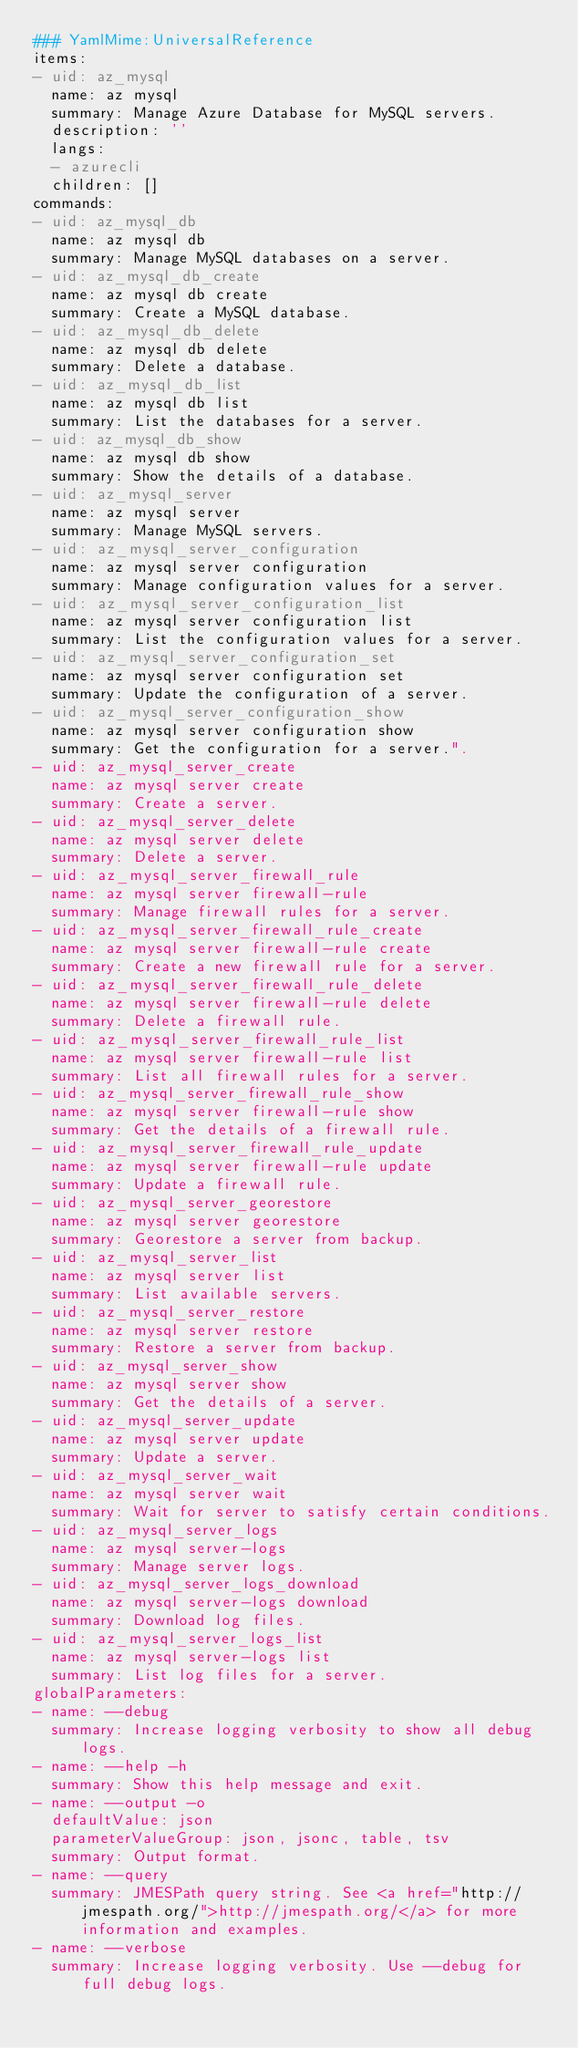Convert code to text. <code><loc_0><loc_0><loc_500><loc_500><_YAML_>### YamlMime:UniversalReference
items:
- uid: az_mysql
  name: az mysql
  summary: Manage Azure Database for MySQL servers.
  description: ''
  langs:
  - azurecli
  children: []
commands:
- uid: az_mysql_db
  name: az mysql db
  summary: Manage MySQL databases on a server.
- uid: az_mysql_db_create
  name: az mysql db create
  summary: Create a MySQL database.
- uid: az_mysql_db_delete
  name: az mysql db delete
  summary: Delete a database.
- uid: az_mysql_db_list
  name: az mysql db list
  summary: List the databases for a server.
- uid: az_mysql_db_show
  name: az mysql db show
  summary: Show the details of a database.
- uid: az_mysql_server
  name: az mysql server
  summary: Manage MySQL servers.
- uid: az_mysql_server_configuration
  name: az mysql server configuration
  summary: Manage configuration values for a server.
- uid: az_mysql_server_configuration_list
  name: az mysql server configuration list
  summary: List the configuration values for a server.
- uid: az_mysql_server_configuration_set
  name: az mysql server configuration set
  summary: Update the configuration of a server.
- uid: az_mysql_server_configuration_show
  name: az mysql server configuration show
  summary: Get the configuration for a server.".
- uid: az_mysql_server_create
  name: az mysql server create
  summary: Create a server.
- uid: az_mysql_server_delete
  name: az mysql server delete
  summary: Delete a server.
- uid: az_mysql_server_firewall_rule
  name: az mysql server firewall-rule
  summary: Manage firewall rules for a server.
- uid: az_mysql_server_firewall_rule_create
  name: az mysql server firewall-rule create
  summary: Create a new firewall rule for a server.
- uid: az_mysql_server_firewall_rule_delete
  name: az mysql server firewall-rule delete
  summary: Delete a firewall rule.
- uid: az_mysql_server_firewall_rule_list
  name: az mysql server firewall-rule list
  summary: List all firewall rules for a server.
- uid: az_mysql_server_firewall_rule_show
  name: az mysql server firewall-rule show
  summary: Get the details of a firewall rule.
- uid: az_mysql_server_firewall_rule_update
  name: az mysql server firewall-rule update
  summary: Update a firewall rule.
- uid: az_mysql_server_georestore
  name: az mysql server georestore
  summary: Georestore a server from backup.
- uid: az_mysql_server_list
  name: az mysql server list
  summary: List available servers.
- uid: az_mysql_server_restore
  name: az mysql server restore
  summary: Restore a server from backup.
- uid: az_mysql_server_show
  name: az mysql server show
  summary: Get the details of a server.
- uid: az_mysql_server_update
  name: az mysql server update
  summary: Update a server.
- uid: az_mysql_server_wait
  name: az mysql server wait
  summary: Wait for server to satisfy certain conditions.
- uid: az_mysql_server_logs
  name: az mysql server-logs
  summary: Manage server logs.
- uid: az_mysql_server_logs_download
  name: az mysql server-logs download
  summary: Download log files.
- uid: az_mysql_server_logs_list
  name: az mysql server-logs list
  summary: List log files for a server.
globalParameters:
- name: --debug
  summary: Increase logging verbosity to show all debug logs.
- name: --help -h
  summary: Show this help message and exit.
- name: --output -o
  defaultValue: json
  parameterValueGroup: json, jsonc, table, tsv
  summary: Output format.
- name: --query
  summary: JMESPath query string. See <a href="http://jmespath.org/">http://jmespath.org/</a> for more information and examples.
- name: --verbose
  summary: Increase logging verbosity. Use --debug for full debug logs.
</code> 